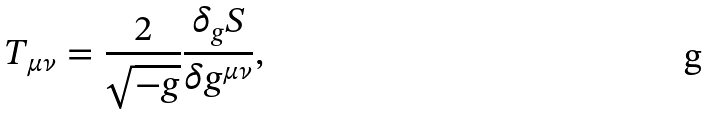<formula> <loc_0><loc_0><loc_500><loc_500>T _ { \mu \nu } = \frac { 2 } { \sqrt { - g } } \frac { \delta _ { g } S } { \delta g ^ { \mu \nu } } ,</formula> 